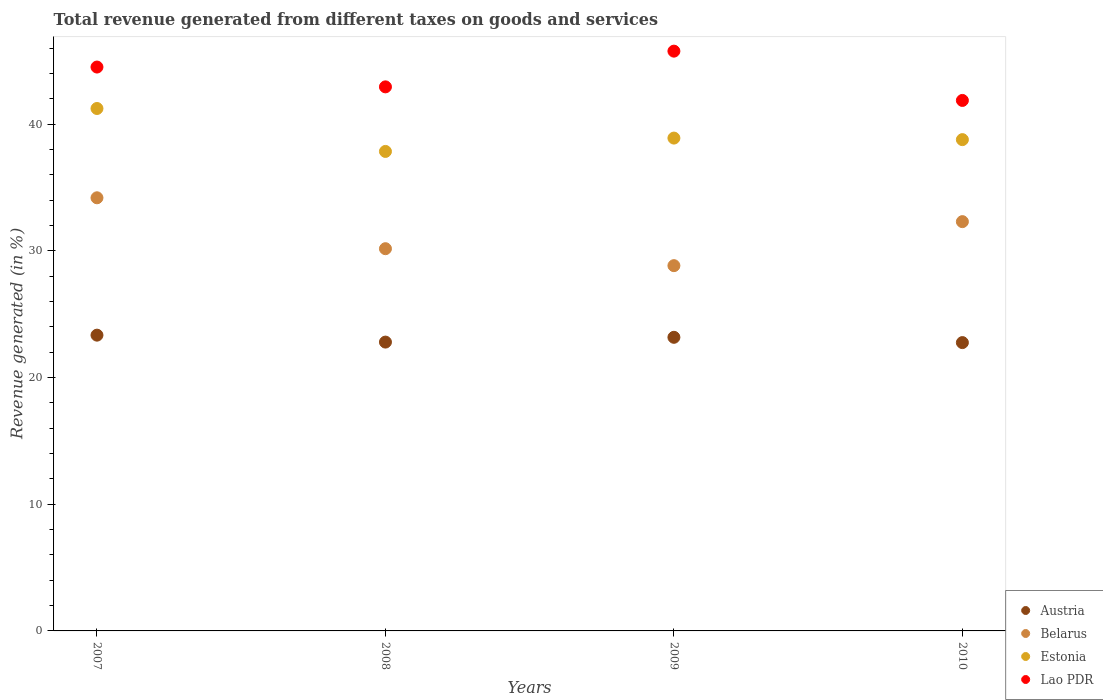What is the total revenue generated in Estonia in 2010?
Offer a terse response. 38.78. Across all years, what is the maximum total revenue generated in Belarus?
Make the answer very short. 34.19. Across all years, what is the minimum total revenue generated in Austria?
Your response must be concise. 22.76. In which year was the total revenue generated in Belarus minimum?
Ensure brevity in your answer.  2009. What is the total total revenue generated in Austria in the graph?
Keep it short and to the point. 92.09. What is the difference between the total revenue generated in Lao PDR in 2007 and that in 2009?
Provide a succinct answer. -1.26. What is the difference between the total revenue generated in Estonia in 2008 and the total revenue generated in Belarus in 2009?
Your answer should be compact. 9.02. What is the average total revenue generated in Estonia per year?
Your answer should be very brief. 39.2. In the year 2007, what is the difference between the total revenue generated in Lao PDR and total revenue generated in Austria?
Offer a very short reply. 21.17. In how many years, is the total revenue generated in Estonia greater than 30 %?
Give a very brief answer. 4. What is the ratio of the total revenue generated in Lao PDR in 2008 to that in 2010?
Make the answer very short. 1.03. Is the total revenue generated in Estonia in 2007 less than that in 2008?
Keep it short and to the point. No. What is the difference between the highest and the second highest total revenue generated in Lao PDR?
Offer a very short reply. 1.26. What is the difference between the highest and the lowest total revenue generated in Belarus?
Offer a very short reply. 5.36. In how many years, is the total revenue generated in Lao PDR greater than the average total revenue generated in Lao PDR taken over all years?
Your answer should be very brief. 2. Is the sum of the total revenue generated in Estonia in 2007 and 2009 greater than the maximum total revenue generated in Belarus across all years?
Offer a very short reply. Yes. Is it the case that in every year, the sum of the total revenue generated in Austria and total revenue generated in Estonia  is greater than the sum of total revenue generated in Lao PDR and total revenue generated in Belarus?
Offer a terse response. Yes. How many dotlines are there?
Provide a short and direct response. 4. How many years are there in the graph?
Offer a very short reply. 4. What is the difference between two consecutive major ticks on the Y-axis?
Your response must be concise. 10. Are the values on the major ticks of Y-axis written in scientific E-notation?
Offer a very short reply. No. Where does the legend appear in the graph?
Provide a short and direct response. Bottom right. What is the title of the graph?
Your answer should be very brief. Total revenue generated from different taxes on goods and services. What is the label or title of the Y-axis?
Offer a terse response. Revenue generated (in %). What is the Revenue generated (in %) of Austria in 2007?
Ensure brevity in your answer.  23.35. What is the Revenue generated (in %) of Belarus in 2007?
Offer a terse response. 34.19. What is the Revenue generated (in %) of Estonia in 2007?
Ensure brevity in your answer.  41.24. What is the Revenue generated (in %) in Lao PDR in 2007?
Your answer should be compact. 44.51. What is the Revenue generated (in %) of Austria in 2008?
Make the answer very short. 22.8. What is the Revenue generated (in %) in Belarus in 2008?
Give a very brief answer. 30.17. What is the Revenue generated (in %) in Estonia in 2008?
Provide a succinct answer. 37.85. What is the Revenue generated (in %) of Lao PDR in 2008?
Offer a very short reply. 42.95. What is the Revenue generated (in %) of Austria in 2009?
Make the answer very short. 23.18. What is the Revenue generated (in %) of Belarus in 2009?
Your response must be concise. 28.84. What is the Revenue generated (in %) of Estonia in 2009?
Provide a short and direct response. 38.91. What is the Revenue generated (in %) in Lao PDR in 2009?
Provide a short and direct response. 45.77. What is the Revenue generated (in %) in Austria in 2010?
Make the answer very short. 22.76. What is the Revenue generated (in %) of Belarus in 2010?
Your answer should be compact. 32.31. What is the Revenue generated (in %) of Estonia in 2010?
Ensure brevity in your answer.  38.78. What is the Revenue generated (in %) in Lao PDR in 2010?
Make the answer very short. 41.88. Across all years, what is the maximum Revenue generated (in %) in Austria?
Keep it short and to the point. 23.35. Across all years, what is the maximum Revenue generated (in %) in Belarus?
Give a very brief answer. 34.19. Across all years, what is the maximum Revenue generated (in %) of Estonia?
Ensure brevity in your answer.  41.24. Across all years, what is the maximum Revenue generated (in %) in Lao PDR?
Your answer should be compact. 45.77. Across all years, what is the minimum Revenue generated (in %) in Austria?
Give a very brief answer. 22.76. Across all years, what is the minimum Revenue generated (in %) in Belarus?
Your response must be concise. 28.84. Across all years, what is the minimum Revenue generated (in %) in Estonia?
Ensure brevity in your answer.  37.85. Across all years, what is the minimum Revenue generated (in %) in Lao PDR?
Offer a terse response. 41.88. What is the total Revenue generated (in %) in Austria in the graph?
Offer a very short reply. 92.09. What is the total Revenue generated (in %) of Belarus in the graph?
Your response must be concise. 125.51. What is the total Revenue generated (in %) of Estonia in the graph?
Ensure brevity in your answer.  156.79. What is the total Revenue generated (in %) in Lao PDR in the graph?
Your answer should be compact. 175.11. What is the difference between the Revenue generated (in %) of Austria in 2007 and that in 2008?
Offer a very short reply. 0.55. What is the difference between the Revenue generated (in %) in Belarus in 2007 and that in 2008?
Keep it short and to the point. 4.02. What is the difference between the Revenue generated (in %) in Estonia in 2007 and that in 2008?
Offer a terse response. 3.39. What is the difference between the Revenue generated (in %) of Lao PDR in 2007 and that in 2008?
Give a very brief answer. 1.56. What is the difference between the Revenue generated (in %) in Austria in 2007 and that in 2009?
Keep it short and to the point. 0.17. What is the difference between the Revenue generated (in %) in Belarus in 2007 and that in 2009?
Your answer should be compact. 5.36. What is the difference between the Revenue generated (in %) of Estonia in 2007 and that in 2009?
Make the answer very short. 2.34. What is the difference between the Revenue generated (in %) in Lao PDR in 2007 and that in 2009?
Provide a short and direct response. -1.26. What is the difference between the Revenue generated (in %) of Austria in 2007 and that in 2010?
Offer a very short reply. 0.59. What is the difference between the Revenue generated (in %) in Belarus in 2007 and that in 2010?
Give a very brief answer. 1.88. What is the difference between the Revenue generated (in %) of Estonia in 2007 and that in 2010?
Offer a terse response. 2.46. What is the difference between the Revenue generated (in %) of Lao PDR in 2007 and that in 2010?
Your answer should be compact. 2.64. What is the difference between the Revenue generated (in %) in Austria in 2008 and that in 2009?
Make the answer very short. -0.38. What is the difference between the Revenue generated (in %) of Belarus in 2008 and that in 2009?
Your response must be concise. 1.34. What is the difference between the Revenue generated (in %) of Estonia in 2008 and that in 2009?
Your response must be concise. -1.05. What is the difference between the Revenue generated (in %) of Lao PDR in 2008 and that in 2009?
Give a very brief answer. -2.82. What is the difference between the Revenue generated (in %) in Austria in 2008 and that in 2010?
Offer a very short reply. 0.04. What is the difference between the Revenue generated (in %) in Belarus in 2008 and that in 2010?
Your answer should be compact. -2.14. What is the difference between the Revenue generated (in %) of Estonia in 2008 and that in 2010?
Give a very brief answer. -0.93. What is the difference between the Revenue generated (in %) of Lao PDR in 2008 and that in 2010?
Give a very brief answer. 1.07. What is the difference between the Revenue generated (in %) in Austria in 2009 and that in 2010?
Offer a very short reply. 0.42. What is the difference between the Revenue generated (in %) of Belarus in 2009 and that in 2010?
Provide a succinct answer. -3.47. What is the difference between the Revenue generated (in %) in Estonia in 2009 and that in 2010?
Offer a terse response. 0.12. What is the difference between the Revenue generated (in %) of Lao PDR in 2009 and that in 2010?
Ensure brevity in your answer.  3.89. What is the difference between the Revenue generated (in %) in Austria in 2007 and the Revenue generated (in %) in Belarus in 2008?
Offer a terse response. -6.83. What is the difference between the Revenue generated (in %) of Austria in 2007 and the Revenue generated (in %) of Estonia in 2008?
Your answer should be compact. -14.5. What is the difference between the Revenue generated (in %) in Austria in 2007 and the Revenue generated (in %) in Lao PDR in 2008?
Provide a succinct answer. -19.6. What is the difference between the Revenue generated (in %) of Belarus in 2007 and the Revenue generated (in %) of Estonia in 2008?
Provide a short and direct response. -3.66. What is the difference between the Revenue generated (in %) in Belarus in 2007 and the Revenue generated (in %) in Lao PDR in 2008?
Your answer should be very brief. -8.76. What is the difference between the Revenue generated (in %) in Estonia in 2007 and the Revenue generated (in %) in Lao PDR in 2008?
Keep it short and to the point. -1.71. What is the difference between the Revenue generated (in %) in Austria in 2007 and the Revenue generated (in %) in Belarus in 2009?
Make the answer very short. -5.49. What is the difference between the Revenue generated (in %) of Austria in 2007 and the Revenue generated (in %) of Estonia in 2009?
Offer a very short reply. -15.56. What is the difference between the Revenue generated (in %) of Austria in 2007 and the Revenue generated (in %) of Lao PDR in 2009?
Ensure brevity in your answer.  -22.42. What is the difference between the Revenue generated (in %) in Belarus in 2007 and the Revenue generated (in %) in Estonia in 2009?
Ensure brevity in your answer.  -4.71. What is the difference between the Revenue generated (in %) in Belarus in 2007 and the Revenue generated (in %) in Lao PDR in 2009?
Provide a succinct answer. -11.58. What is the difference between the Revenue generated (in %) in Estonia in 2007 and the Revenue generated (in %) in Lao PDR in 2009?
Offer a terse response. -4.53. What is the difference between the Revenue generated (in %) in Austria in 2007 and the Revenue generated (in %) in Belarus in 2010?
Ensure brevity in your answer.  -8.96. What is the difference between the Revenue generated (in %) of Austria in 2007 and the Revenue generated (in %) of Estonia in 2010?
Provide a short and direct response. -15.44. What is the difference between the Revenue generated (in %) of Austria in 2007 and the Revenue generated (in %) of Lao PDR in 2010?
Offer a terse response. -18.53. What is the difference between the Revenue generated (in %) in Belarus in 2007 and the Revenue generated (in %) in Estonia in 2010?
Keep it short and to the point. -4.59. What is the difference between the Revenue generated (in %) of Belarus in 2007 and the Revenue generated (in %) of Lao PDR in 2010?
Provide a short and direct response. -7.69. What is the difference between the Revenue generated (in %) in Estonia in 2007 and the Revenue generated (in %) in Lao PDR in 2010?
Ensure brevity in your answer.  -0.64. What is the difference between the Revenue generated (in %) in Austria in 2008 and the Revenue generated (in %) in Belarus in 2009?
Provide a succinct answer. -6.03. What is the difference between the Revenue generated (in %) of Austria in 2008 and the Revenue generated (in %) of Estonia in 2009?
Your answer should be compact. -16.11. What is the difference between the Revenue generated (in %) of Austria in 2008 and the Revenue generated (in %) of Lao PDR in 2009?
Provide a succinct answer. -22.97. What is the difference between the Revenue generated (in %) in Belarus in 2008 and the Revenue generated (in %) in Estonia in 2009?
Your answer should be compact. -8.73. What is the difference between the Revenue generated (in %) of Belarus in 2008 and the Revenue generated (in %) of Lao PDR in 2009?
Give a very brief answer. -15.6. What is the difference between the Revenue generated (in %) of Estonia in 2008 and the Revenue generated (in %) of Lao PDR in 2009?
Your answer should be very brief. -7.92. What is the difference between the Revenue generated (in %) in Austria in 2008 and the Revenue generated (in %) in Belarus in 2010?
Your answer should be very brief. -9.51. What is the difference between the Revenue generated (in %) in Austria in 2008 and the Revenue generated (in %) in Estonia in 2010?
Your answer should be very brief. -15.98. What is the difference between the Revenue generated (in %) in Austria in 2008 and the Revenue generated (in %) in Lao PDR in 2010?
Provide a short and direct response. -19.08. What is the difference between the Revenue generated (in %) of Belarus in 2008 and the Revenue generated (in %) of Estonia in 2010?
Give a very brief answer. -8.61. What is the difference between the Revenue generated (in %) in Belarus in 2008 and the Revenue generated (in %) in Lao PDR in 2010?
Keep it short and to the point. -11.7. What is the difference between the Revenue generated (in %) in Estonia in 2008 and the Revenue generated (in %) in Lao PDR in 2010?
Keep it short and to the point. -4.03. What is the difference between the Revenue generated (in %) of Austria in 2009 and the Revenue generated (in %) of Belarus in 2010?
Keep it short and to the point. -9.13. What is the difference between the Revenue generated (in %) of Austria in 2009 and the Revenue generated (in %) of Estonia in 2010?
Keep it short and to the point. -15.61. What is the difference between the Revenue generated (in %) of Austria in 2009 and the Revenue generated (in %) of Lao PDR in 2010?
Your response must be concise. -18.7. What is the difference between the Revenue generated (in %) in Belarus in 2009 and the Revenue generated (in %) in Estonia in 2010?
Your answer should be compact. -9.95. What is the difference between the Revenue generated (in %) in Belarus in 2009 and the Revenue generated (in %) in Lao PDR in 2010?
Make the answer very short. -13.04. What is the difference between the Revenue generated (in %) in Estonia in 2009 and the Revenue generated (in %) in Lao PDR in 2010?
Ensure brevity in your answer.  -2.97. What is the average Revenue generated (in %) of Austria per year?
Offer a terse response. 23.02. What is the average Revenue generated (in %) in Belarus per year?
Ensure brevity in your answer.  31.38. What is the average Revenue generated (in %) of Estonia per year?
Ensure brevity in your answer.  39.2. What is the average Revenue generated (in %) of Lao PDR per year?
Your response must be concise. 43.78. In the year 2007, what is the difference between the Revenue generated (in %) in Austria and Revenue generated (in %) in Belarus?
Provide a succinct answer. -10.84. In the year 2007, what is the difference between the Revenue generated (in %) in Austria and Revenue generated (in %) in Estonia?
Your answer should be compact. -17.89. In the year 2007, what is the difference between the Revenue generated (in %) of Austria and Revenue generated (in %) of Lao PDR?
Provide a short and direct response. -21.17. In the year 2007, what is the difference between the Revenue generated (in %) in Belarus and Revenue generated (in %) in Estonia?
Make the answer very short. -7.05. In the year 2007, what is the difference between the Revenue generated (in %) of Belarus and Revenue generated (in %) of Lao PDR?
Ensure brevity in your answer.  -10.32. In the year 2007, what is the difference between the Revenue generated (in %) of Estonia and Revenue generated (in %) of Lao PDR?
Give a very brief answer. -3.27. In the year 2008, what is the difference between the Revenue generated (in %) in Austria and Revenue generated (in %) in Belarus?
Provide a short and direct response. -7.37. In the year 2008, what is the difference between the Revenue generated (in %) in Austria and Revenue generated (in %) in Estonia?
Your answer should be very brief. -15.05. In the year 2008, what is the difference between the Revenue generated (in %) in Austria and Revenue generated (in %) in Lao PDR?
Keep it short and to the point. -20.15. In the year 2008, what is the difference between the Revenue generated (in %) of Belarus and Revenue generated (in %) of Estonia?
Give a very brief answer. -7.68. In the year 2008, what is the difference between the Revenue generated (in %) in Belarus and Revenue generated (in %) in Lao PDR?
Your answer should be very brief. -12.78. In the year 2008, what is the difference between the Revenue generated (in %) in Estonia and Revenue generated (in %) in Lao PDR?
Your response must be concise. -5.1. In the year 2009, what is the difference between the Revenue generated (in %) in Austria and Revenue generated (in %) in Belarus?
Your answer should be very brief. -5.66. In the year 2009, what is the difference between the Revenue generated (in %) of Austria and Revenue generated (in %) of Estonia?
Your answer should be compact. -15.73. In the year 2009, what is the difference between the Revenue generated (in %) of Austria and Revenue generated (in %) of Lao PDR?
Give a very brief answer. -22.59. In the year 2009, what is the difference between the Revenue generated (in %) in Belarus and Revenue generated (in %) in Estonia?
Give a very brief answer. -10.07. In the year 2009, what is the difference between the Revenue generated (in %) of Belarus and Revenue generated (in %) of Lao PDR?
Make the answer very short. -16.93. In the year 2009, what is the difference between the Revenue generated (in %) in Estonia and Revenue generated (in %) in Lao PDR?
Give a very brief answer. -6.86. In the year 2010, what is the difference between the Revenue generated (in %) of Austria and Revenue generated (in %) of Belarus?
Give a very brief answer. -9.55. In the year 2010, what is the difference between the Revenue generated (in %) in Austria and Revenue generated (in %) in Estonia?
Offer a terse response. -16.02. In the year 2010, what is the difference between the Revenue generated (in %) of Austria and Revenue generated (in %) of Lao PDR?
Your answer should be very brief. -19.12. In the year 2010, what is the difference between the Revenue generated (in %) in Belarus and Revenue generated (in %) in Estonia?
Provide a short and direct response. -6.47. In the year 2010, what is the difference between the Revenue generated (in %) in Belarus and Revenue generated (in %) in Lao PDR?
Offer a terse response. -9.57. In the year 2010, what is the difference between the Revenue generated (in %) in Estonia and Revenue generated (in %) in Lao PDR?
Give a very brief answer. -3.09. What is the ratio of the Revenue generated (in %) of Austria in 2007 to that in 2008?
Your answer should be compact. 1.02. What is the ratio of the Revenue generated (in %) of Belarus in 2007 to that in 2008?
Your response must be concise. 1.13. What is the ratio of the Revenue generated (in %) in Estonia in 2007 to that in 2008?
Offer a terse response. 1.09. What is the ratio of the Revenue generated (in %) in Lao PDR in 2007 to that in 2008?
Your response must be concise. 1.04. What is the ratio of the Revenue generated (in %) of Austria in 2007 to that in 2009?
Offer a very short reply. 1.01. What is the ratio of the Revenue generated (in %) of Belarus in 2007 to that in 2009?
Keep it short and to the point. 1.19. What is the ratio of the Revenue generated (in %) of Estonia in 2007 to that in 2009?
Your answer should be very brief. 1.06. What is the ratio of the Revenue generated (in %) of Lao PDR in 2007 to that in 2009?
Provide a succinct answer. 0.97. What is the ratio of the Revenue generated (in %) of Austria in 2007 to that in 2010?
Provide a short and direct response. 1.03. What is the ratio of the Revenue generated (in %) in Belarus in 2007 to that in 2010?
Keep it short and to the point. 1.06. What is the ratio of the Revenue generated (in %) in Estonia in 2007 to that in 2010?
Provide a succinct answer. 1.06. What is the ratio of the Revenue generated (in %) of Lao PDR in 2007 to that in 2010?
Ensure brevity in your answer.  1.06. What is the ratio of the Revenue generated (in %) in Austria in 2008 to that in 2009?
Your answer should be compact. 0.98. What is the ratio of the Revenue generated (in %) of Belarus in 2008 to that in 2009?
Ensure brevity in your answer.  1.05. What is the ratio of the Revenue generated (in %) of Estonia in 2008 to that in 2009?
Give a very brief answer. 0.97. What is the ratio of the Revenue generated (in %) of Lao PDR in 2008 to that in 2009?
Provide a short and direct response. 0.94. What is the ratio of the Revenue generated (in %) of Belarus in 2008 to that in 2010?
Provide a succinct answer. 0.93. What is the ratio of the Revenue generated (in %) of Estonia in 2008 to that in 2010?
Give a very brief answer. 0.98. What is the ratio of the Revenue generated (in %) in Lao PDR in 2008 to that in 2010?
Provide a short and direct response. 1.03. What is the ratio of the Revenue generated (in %) of Austria in 2009 to that in 2010?
Make the answer very short. 1.02. What is the ratio of the Revenue generated (in %) in Belarus in 2009 to that in 2010?
Ensure brevity in your answer.  0.89. What is the ratio of the Revenue generated (in %) in Lao PDR in 2009 to that in 2010?
Provide a short and direct response. 1.09. What is the difference between the highest and the second highest Revenue generated (in %) of Austria?
Provide a succinct answer. 0.17. What is the difference between the highest and the second highest Revenue generated (in %) of Belarus?
Your answer should be compact. 1.88. What is the difference between the highest and the second highest Revenue generated (in %) in Estonia?
Your response must be concise. 2.34. What is the difference between the highest and the second highest Revenue generated (in %) of Lao PDR?
Make the answer very short. 1.26. What is the difference between the highest and the lowest Revenue generated (in %) of Austria?
Ensure brevity in your answer.  0.59. What is the difference between the highest and the lowest Revenue generated (in %) of Belarus?
Provide a succinct answer. 5.36. What is the difference between the highest and the lowest Revenue generated (in %) of Estonia?
Give a very brief answer. 3.39. What is the difference between the highest and the lowest Revenue generated (in %) of Lao PDR?
Provide a short and direct response. 3.89. 